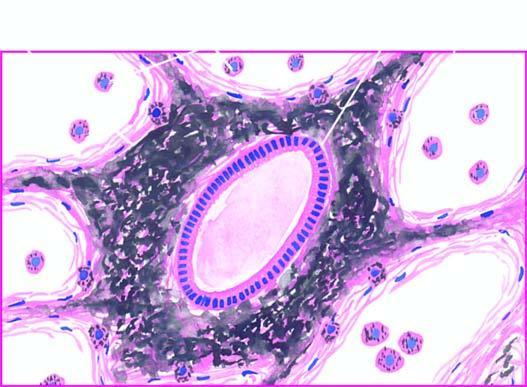s there presence of abundant coarse black carbon pigment in the septal walls and around the bronchiole?
Answer the question using a single word or phrase. Yes 